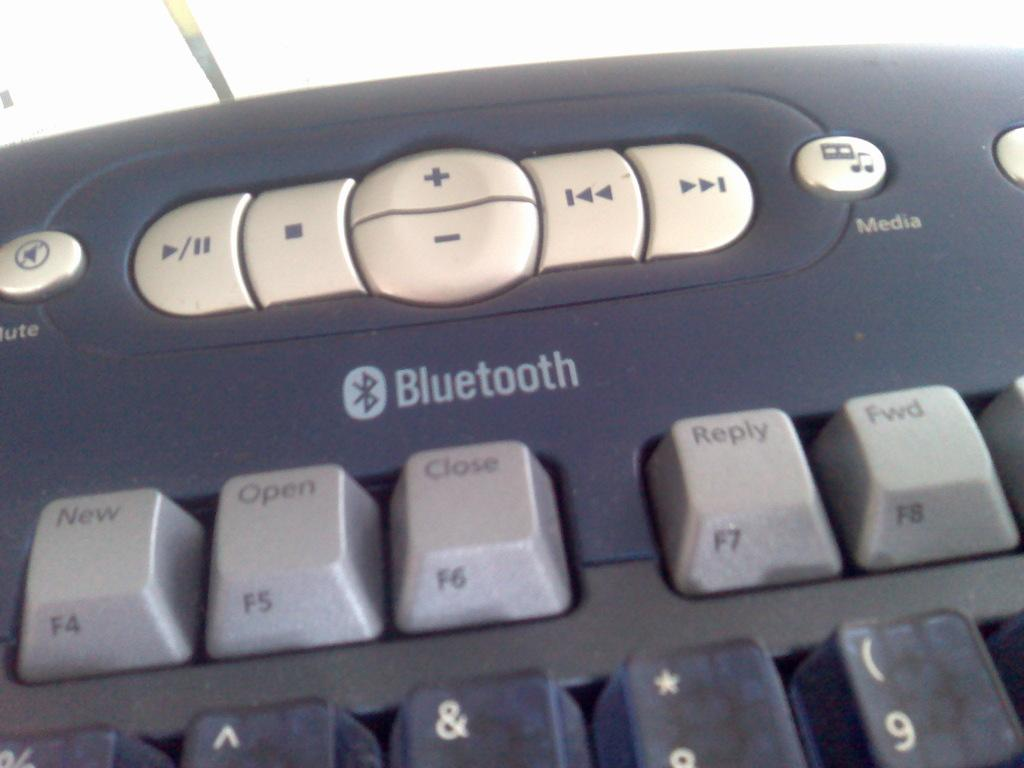<image>
Describe the image concisely. A keyboard with a logo that says Bluetooth has many keys. 